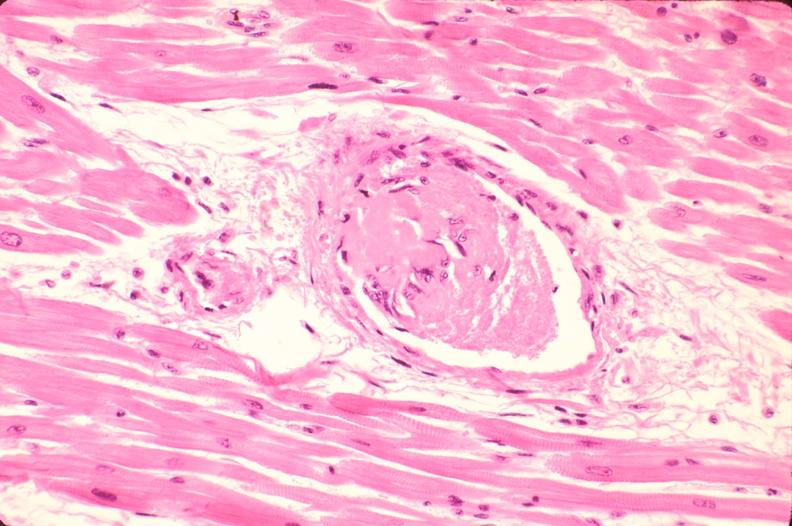s tuberculosis present?
Answer the question using a single word or phrase. No 